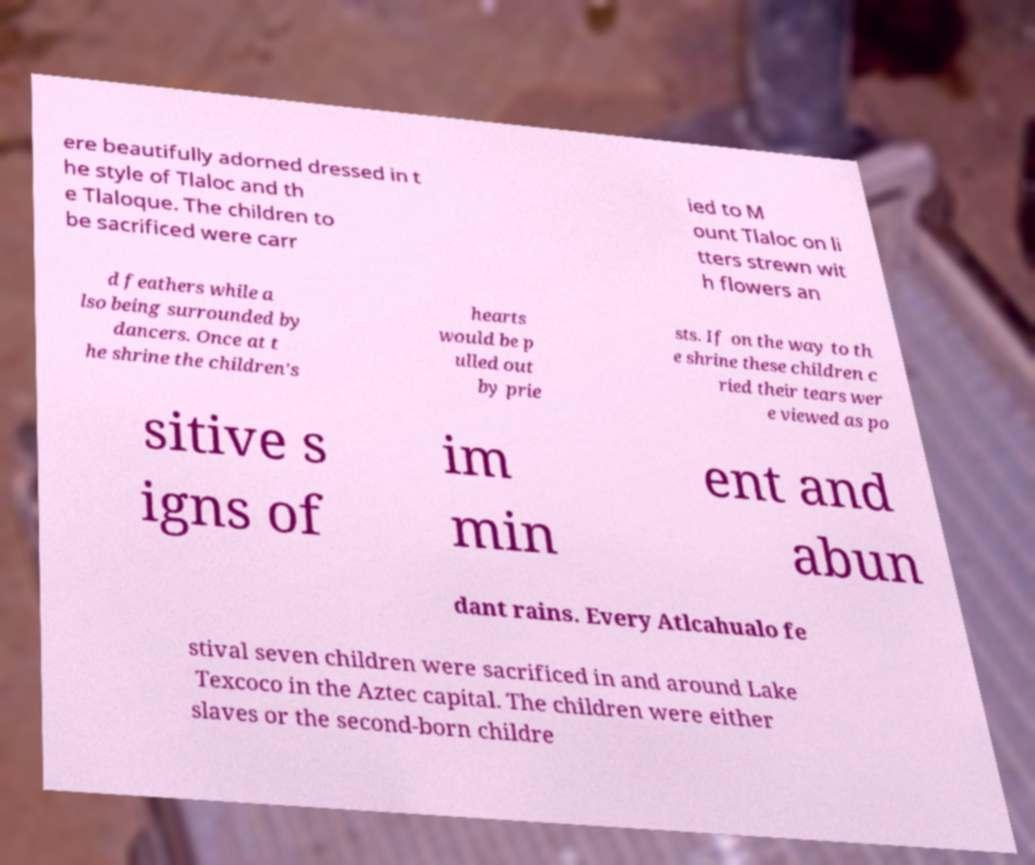Can you read and provide the text displayed in the image?This photo seems to have some interesting text. Can you extract and type it out for me? ere beautifully adorned dressed in t he style of Tlaloc and th e Tlaloque. The children to be sacrificed were carr ied to M ount Tlaloc on li tters strewn wit h flowers an d feathers while a lso being surrounded by dancers. Once at t he shrine the children's hearts would be p ulled out by prie sts. If on the way to th e shrine these children c ried their tears wer e viewed as po sitive s igns of im min ent and abun dant rains. Every Atlcahualo fe stival seven children were sacrificed in and around Lake Texcoco in the Aztec capital. The children were either slaves or the second-born childre 